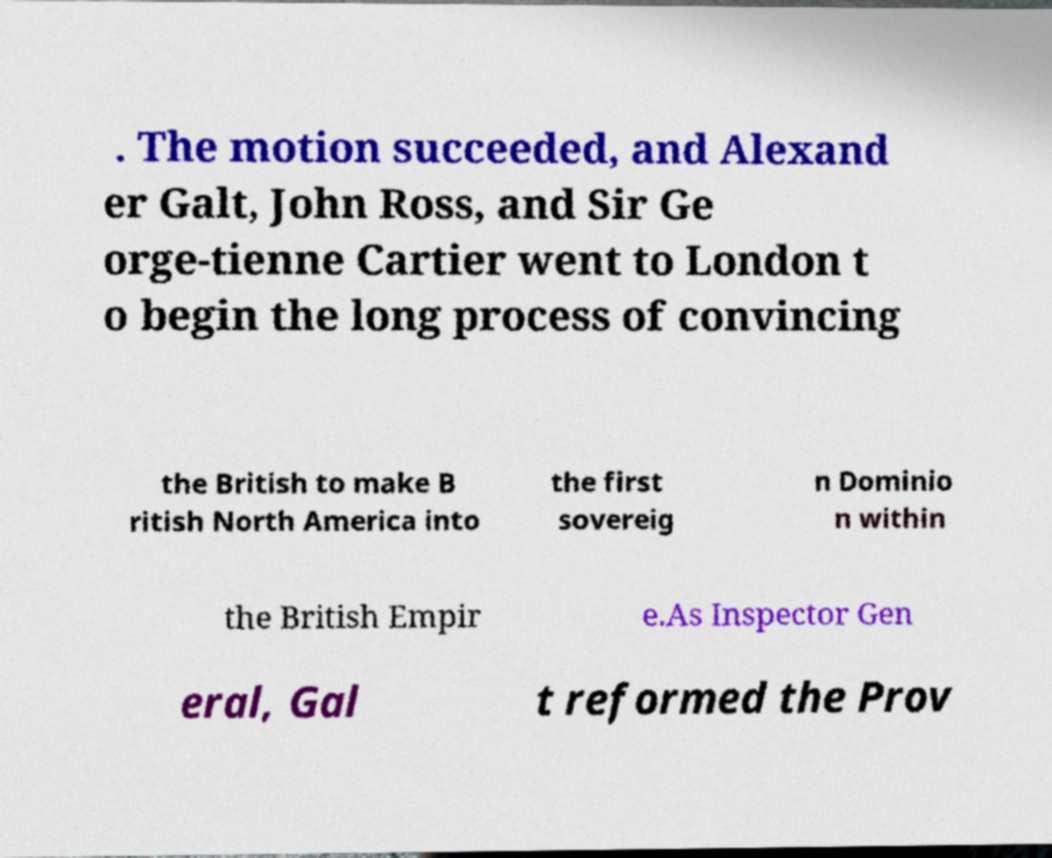Can you accurately transcribe the text from the provided image for me? . The motion succeeded, and Alexand er Galt, John Ross, and Sir Ge orge-tienne Cartier went to London t o begin the long process of convincing the British to make B ritish North America into the first sovereig n Dominio n within the British Empir e.As Inspector Gen eral, Gal t reformed the Prov 